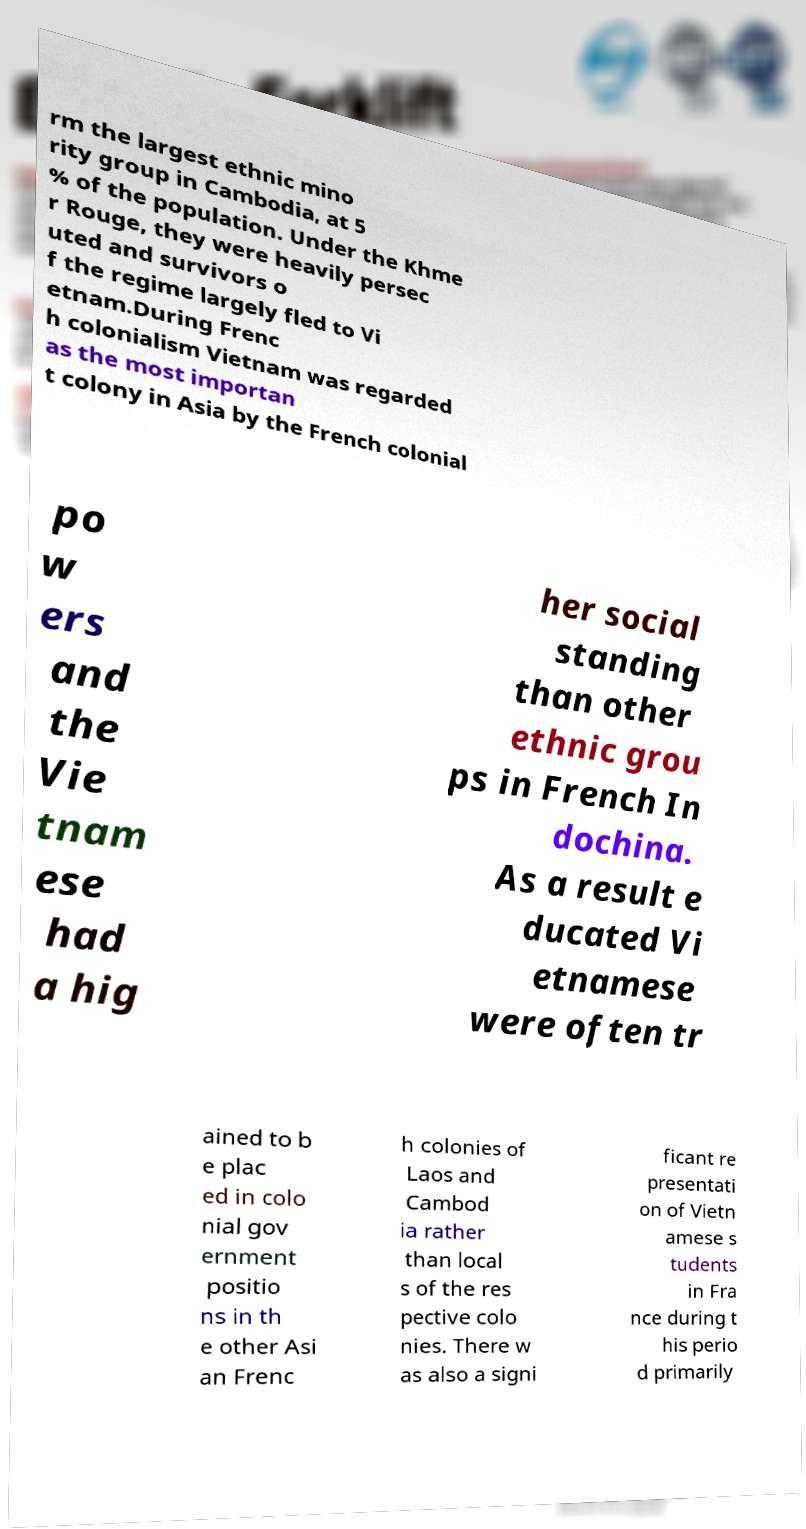I need the written content from this picture converted into text. Can you do that? rm the largest ethnic mino rity group in Cambodia, at 5 % of the population. Under the Khme r Rouge, they were heavily persec uted and survivors o f the regime largely fled to Vi etnam.During Frenc h colonialism Vietnam was regarded as the most importan t colony in Asia by the French colonial po w ers and the Vie tnam ese had a hig her social standing than other ethnic grou ps in French In dochina. As a result e ducated Vi etnamese were often tr ained to b e plac ed in colo nial gov ernment positio ns in th e other Asi an Frenc h colonies of Laos and Cambod ia rather than local s of the res pective colo nies. There w as also a signi ficant re presentati on of Vietn amese s tudents in Fra nce during t his perio d primarily 